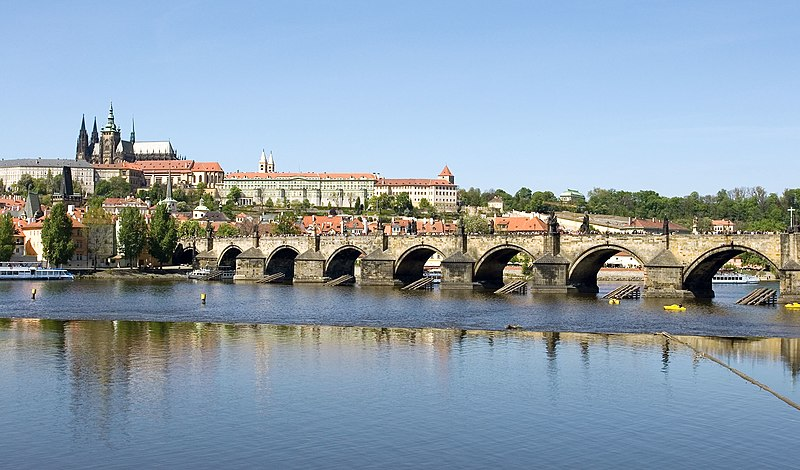What historical period does this bridge come from, and can you tell me more about its significance? The Charles Bridge has its origins in the 14th century, commissioned by King Charles IV in 1357. It replaced an older bridge that collapsed due to a flood. For centuries, it was the most important connection between Prague Castle and the city's Old Town and surrounding areas. This bridge has witnessed numerous historical events and withstood the test of time, symbolizing the resilience and history of Prague. Notably, it's adorned with baroque statues mainly from the 17th and 18th centuries, which were intended to showcase the artistic and religious spirit of the city. 